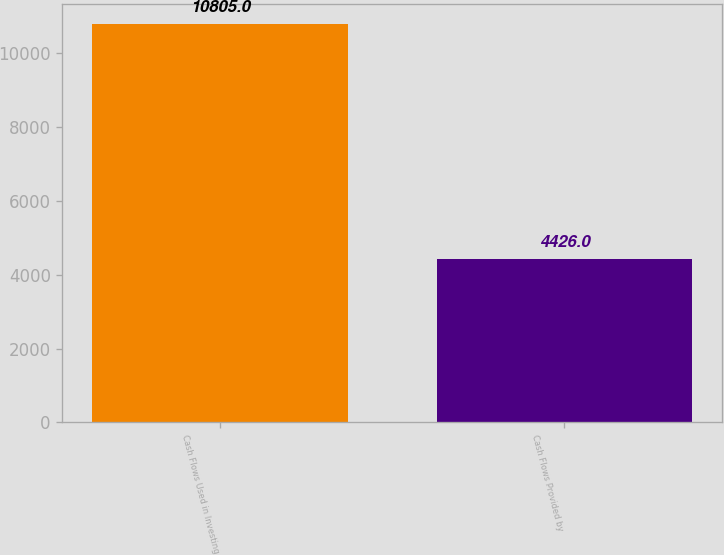Convert chart. <chart><loc_0><loc_0><loc_500><loc_500><bar_chart><fcel>Cash Flows Used in Investing<fcel>Cash Flows Provided by<nl><fcel>10805<fcel>4426<nl></chart> 